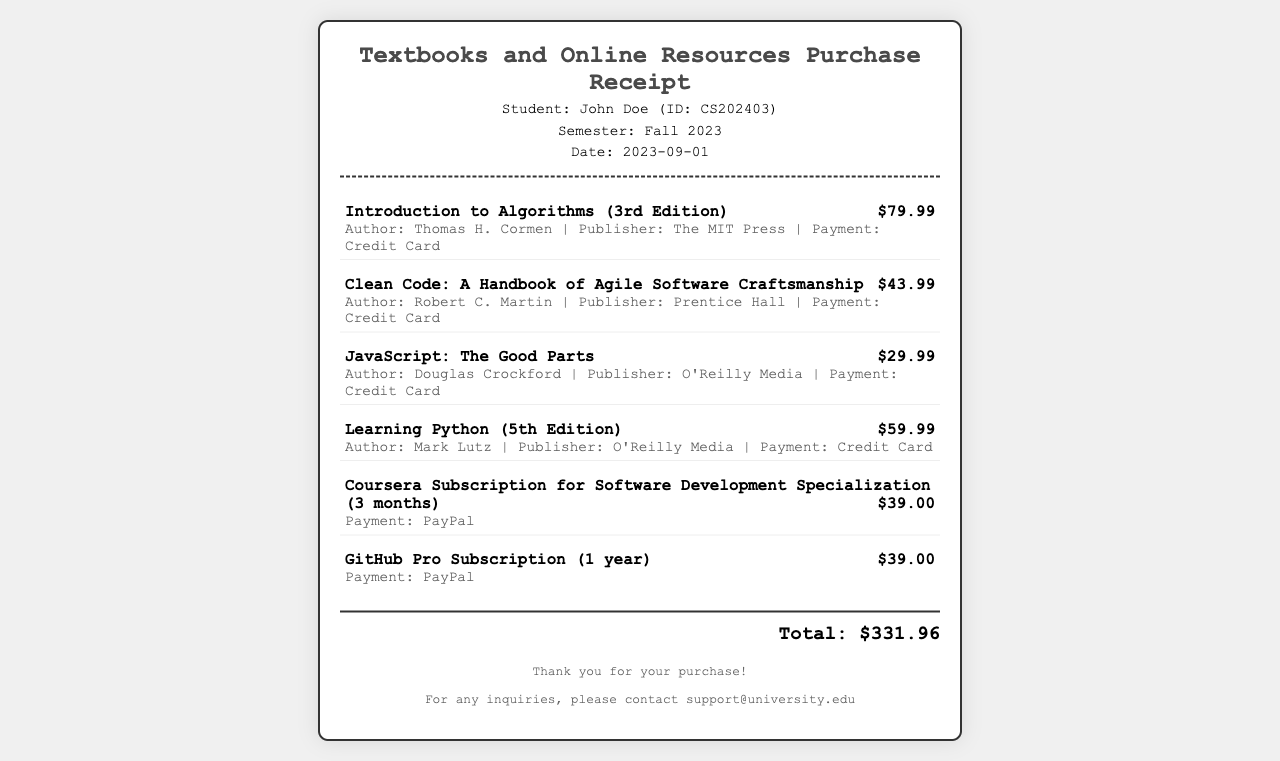What is the total amount spent on textbooks and online resources? The total amount is displayed clearly at the bottom of the receipt, summing up all individual item prices.
Answer: $331.96 Who is the author of "Clean Code"? The receipt lists the author's name next to the book title under item details.
Answer: Robert C. Martin What payment method was used for the JavaScript book? The payment method is specified in the item details for that particular book.
Answer: Credit Card How many months does the Coursera subscription cover? The subscription duration is indicated in the item description of the receipt.
Answer: 3 months Which item has the highest cost? By comparing item costs listed in the receipt, the most expensive item can be identified.
Answer: Introduction to Algorithms (3rd Edition) What is the date of the purchase? The date of the transaction is provided in the header section of the receipt.
Answer: 2023-09-01 What type of document is this? The title at the top of the receipt indicates what the document is related to.
Answer: Receipt How many items were purchased in total? Counting all the item entries listed in the document gives the total number of items purchased.
Answer: 6 items 